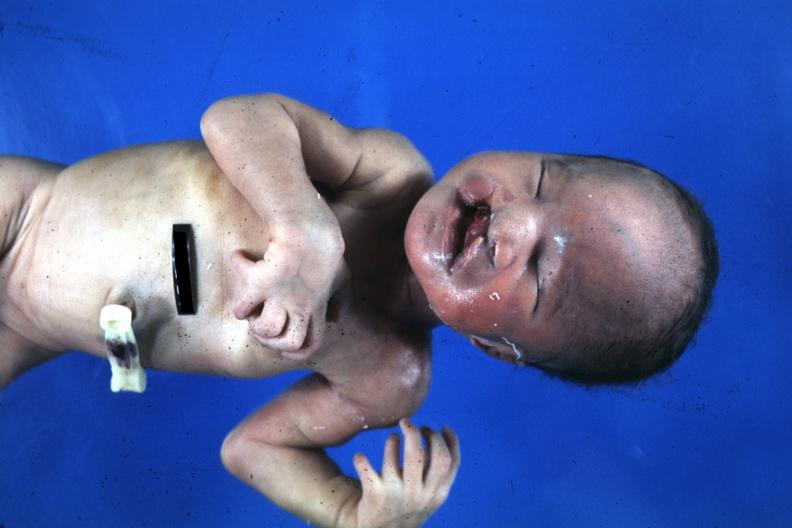what is present?
Answer the question using a single word or phrase. Face 